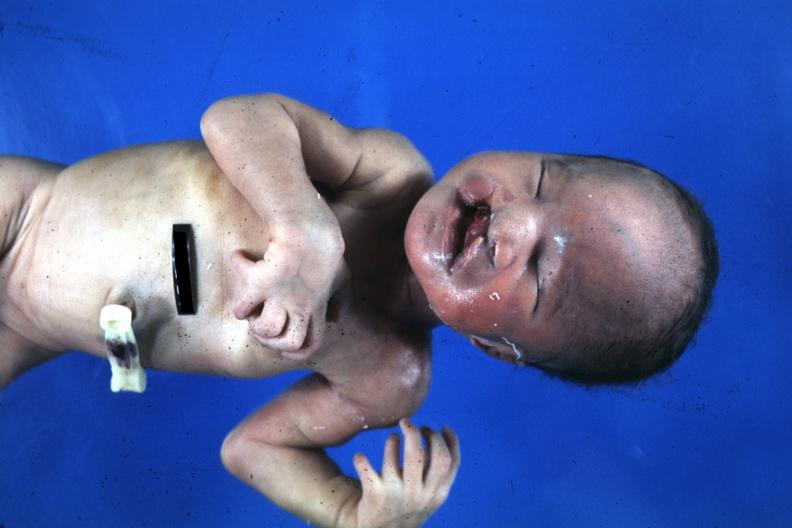what is present?
Answer the question using a single word or phrase. Face 